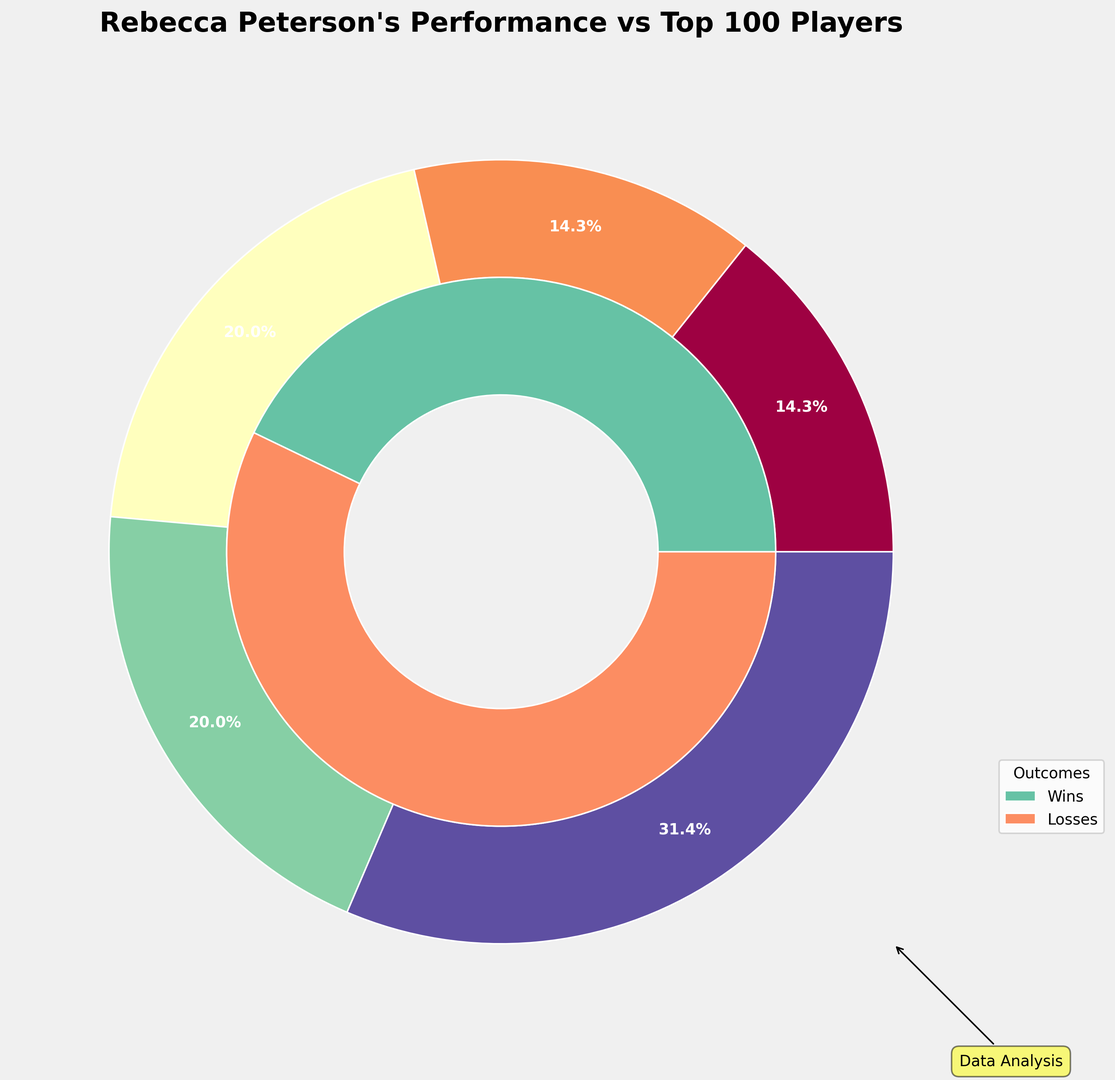What percentage of matches did Rebecca Peterson win against players ranked between 51-75? First, identify that the number of matches won against players ranked 51-75 is 8. Next, calculate the total number of matches played against this rank bracket which is 8 (wins) + 6 (losses) = 14. The percentage is then (8 / 14) * 100 = 57.1%.
Answer: 57.1% Does Rebecca Peterson have more wins or losses against players ranked 1-10? Compare the matches won (2) with the matches lost (8) against players ranked 1-10. There are more losses than wins.
Answer: Losses Which rank bracket does Rebecca Peterson have the highest win percentage against? Calculate the win percentage for each rank bracket and identify the highest. The calculations are as follows: (2/10)*100=20% for 1-10, (3/10)*100=30% for 11-25, (5/14)*100=35.7% for 26-50, (8/14)*100=57.1% for 51-75, (12/22)*100≈54.5% for 76-100. The highest win percentage is 57.1% against players ranked 51-75.
Answer: 51-75 How many more matches has Rebecca Peterson played against players ranked 76-100 compared to 1-10? First, find the total matches for both rank brackets: 76-100 is 12 (wins) + 10 (losses) = 22; 1-10 is 2 (wins) + 8 (losses) = 10. The difference is 22 - 10 = 12.
Answer: 12 In which rank bracket does Rebecca Peterson have the smallest difference between wins and losses? Calculate the difference between wins and losses for each rank bracket: 1-10 is 8-2=6, 11-25 is 7-3=4, 26-50 is 9-5=4, 51-75 is 8-6=2, 76-100 is 10-12=2. The smallest difference is 2, occurring in the 51-75 and 76-100 brackets.
Answer: 51-75 and 76-100 What portion of all her matches against top 100 players resulted in wins? Calculate the total wins and total matches: Total wins are 2+3+5+8+12=30, and total matches are 2+8+3+7+5+9+8+6+12+10=70. The portion of wins is 30/70 = 0.4286 or 42.9%.
Answer: 42.9% What is more, the total number of matches won or lost by Rebecca Peterson? Total wins are 2+3+5+8+12=30, and total losses are 8+7+9+6+10=40. There are more losses than wins.
Answer: Total losses Which part of the pie chart is larger: wins against players ranked 26-50 or losses against players ranked 51-75? Identify the relevant sections: wins against 26-50 are 5, losses against 51-75 are 6. Losses against players ranked 51-75 are larger.
Answer: Losses against 51-75 